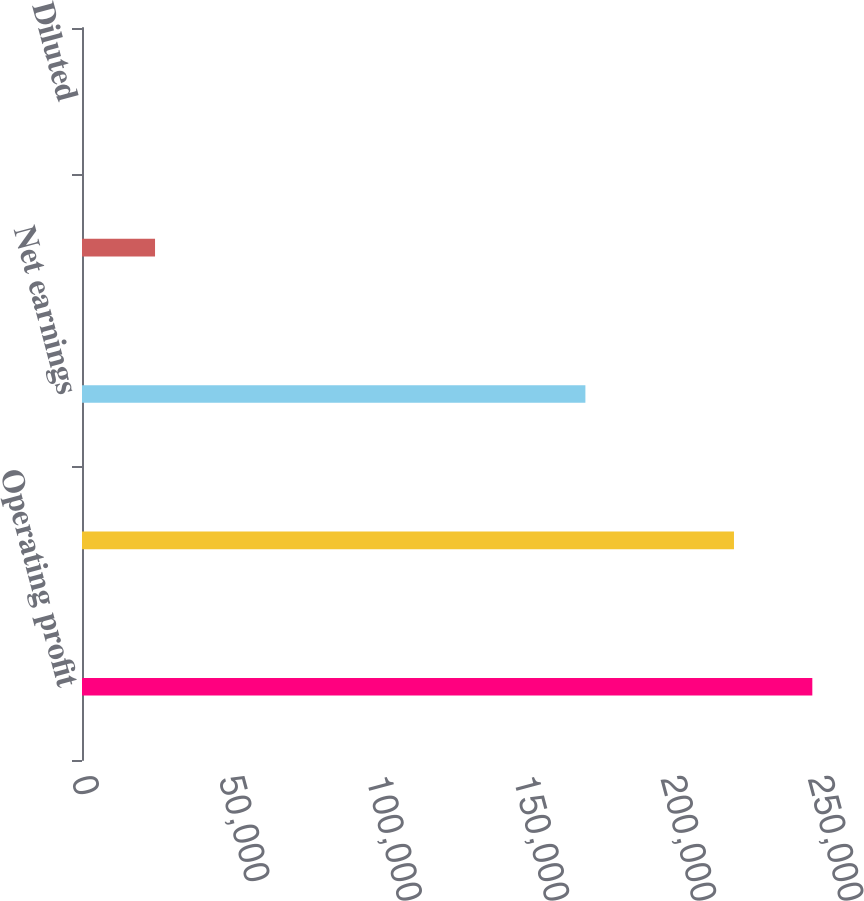Convert chart to OTSL. <chart><loc_0><loc_0><loc_500><loc_500><bar_chart><fcel>Operating profit<fcel>Earnings before income taxes<fcel>Net earnings<fcel>Basic<fcel>Diluted<nl><fcel>248072<fcel>221457<fcel>170990<fcel>24808.3<fcel>1.27<nl></chart> 